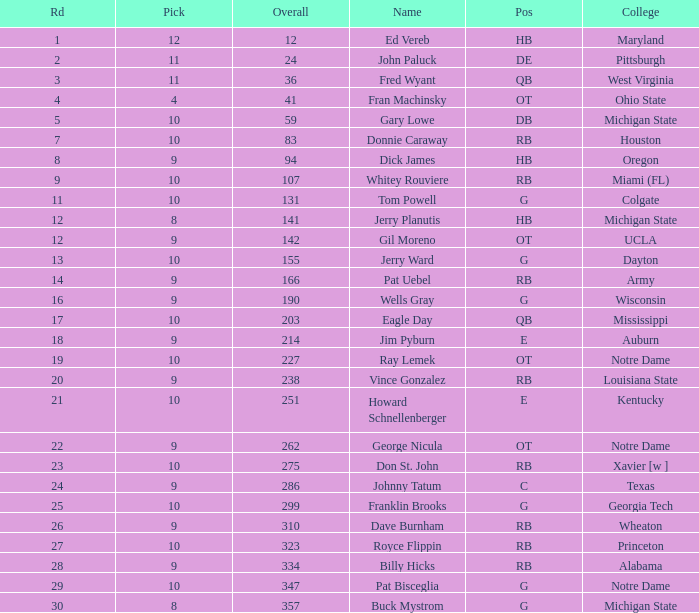What is the average number of rounds for billy hicks who had an overall pick number bigger than 310? 28.0. Could you parse the entire table? {'header': ['Rd', 'Pick', 'Overall', 'Name', 'Pos', 'College'], 'rows': [['1', '12', '12', 'Ed Vereb', 'HB', 'Maryland'], ['2', '11', '24', 'John Paluck', 'DE', 'Pittsburgh'], ['3', '11', '36', 'Fred Wyant', 'QB', 'West Virginia'], ['4', '4', '41', 'Fran Machinsky', 'OT', 'Ohio State'], ['5', '10', '59', 'Gary Lowe', 'DB', 'Michigan State'], ['7', '10', '83', 'Donnie Caraway', 'RB', 'Houston'], ['8', '9', '94', 'Dick James', 'HB', 'Oregon'], ['9', '10', '107', 'Whitey Rouviere', 'RB', 'Miami (FL)'], ['11', '10', '131', 'Tom Powell', 'G', 'Colgate'], ['12', '8', '141', 'Jerry Planutis', 'HB', 'Michigan State'], ['12', '9', '142', 'Gil Moreno', 'OT', 'UCLA'], ['13', '10', '155', 'Jerry Ward', 'G', 'Dayton'], ['14', '9', '166', 'Pat Uebel', 'RB', 'Army'], ['16', '9', '190', 'Wells Gray', 'G', 'Wisconsin'], ['17', '10', '203', 'Eagle Day', 'QB', 'Mississippi'], ['18', '9', '214', 'Jim Pyburn', 'E', 'Auburn'], ['19', '10', '227', 'Ray Lemek', 'OT', 'Notre Dame'], ['20', '9', '238', 'Vince Gonzalez', 'RB', 'Louisiana State'], ['21', '10', '251', 'Howard Schnellenberger', 'E', 'Kentucky'], ['22', '9', '262', 'George Nicula', 'OT', 'Notre Dame'], ['23', '10', '275', 'Don St. John', 'RB', 'Xavier [w ]'], ['24', '9', '286', 'Johnny Tatum', 'C', 'Texas'], ['25', '10', '299', 'Franklin Brooks', 'G', 'Georgia Tech'], ['26', '9', '310', 'Dave Burnham', 'RB', 'Wheaton'], ['27', '10', '323', 'Royce Flippin', 'RB', 'Princeton'], ['28', '9', '334', 'Billy Hicks', 'RB', 'Alabama'], ['29', '10', '347', 'Pat Bisceglia', 'G', 'Notre Dame'], ['30', '8', '357', 'Buck Mystrom', 'G', 'Michigan State']]} 